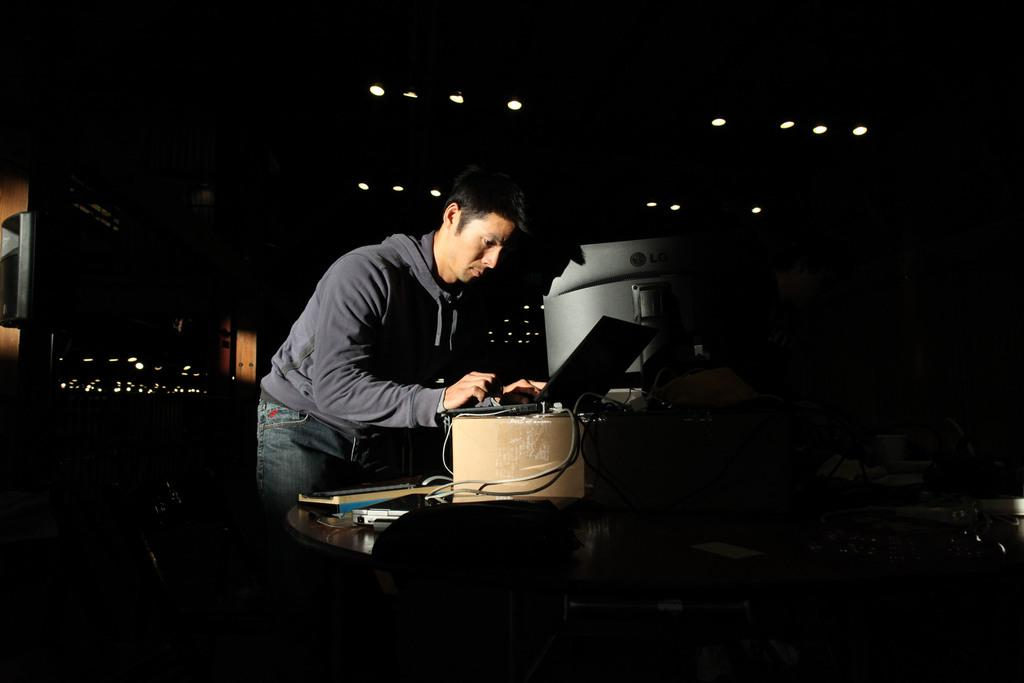What is located at the bottom of the image? There is a table at the bottom of the image. What can be seen on the table? There are wires and a laptop on the table. Who is present in the image? A person is standing behind the table. What is visible behind the person? There are lights visible behind the person. What type of war is being fought in the image? There is no war present in the image; it features a table with wires, a laptop, and a person standing behind it. How many wheels can be seen on the laptop in the image? The laptop does not have wheels; it is a flat device with a screen and keyboard. 